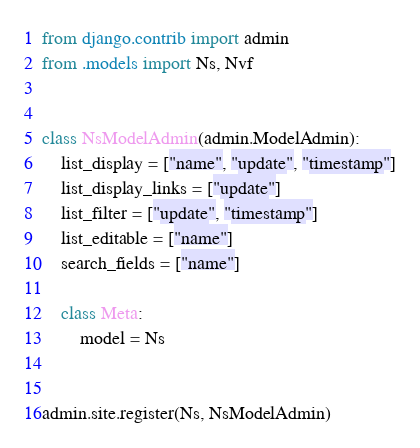<code> <loc_0><loc_0><loc_500><loc_500><_Python_>from django.contrib import admin
from .models import Ns, Nvf


class NsModelAdmin(admin.ModelAdmin):
    list_display = ["name", "update", "timestamp"]
    list_display_links = ["update"]
    list_filter = ["update", "timestamp"]
    list_editable = ["name"]
    search_fields = ["name"]

    class Meta:
        model = Ns


admin.site.register(Ns, NsModelAdmin)

</code> 